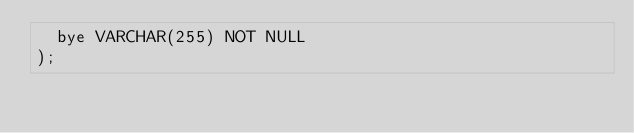<code> <loc_0><loc_0><loc_500><loc_500><_SQL_>  bye VARCHAR(255) NOT NULL
);
</code> 